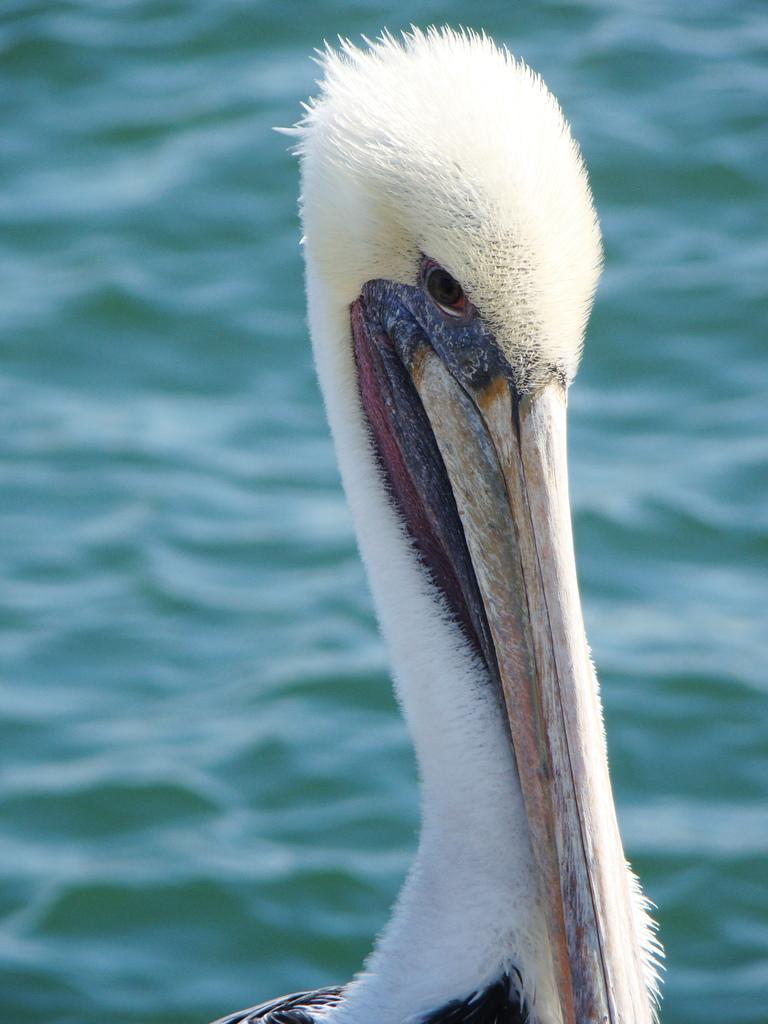Can you describe this image briefly? In this image I can see a bird which is black, white and red in color and in the background I can see the water which are green in color. 